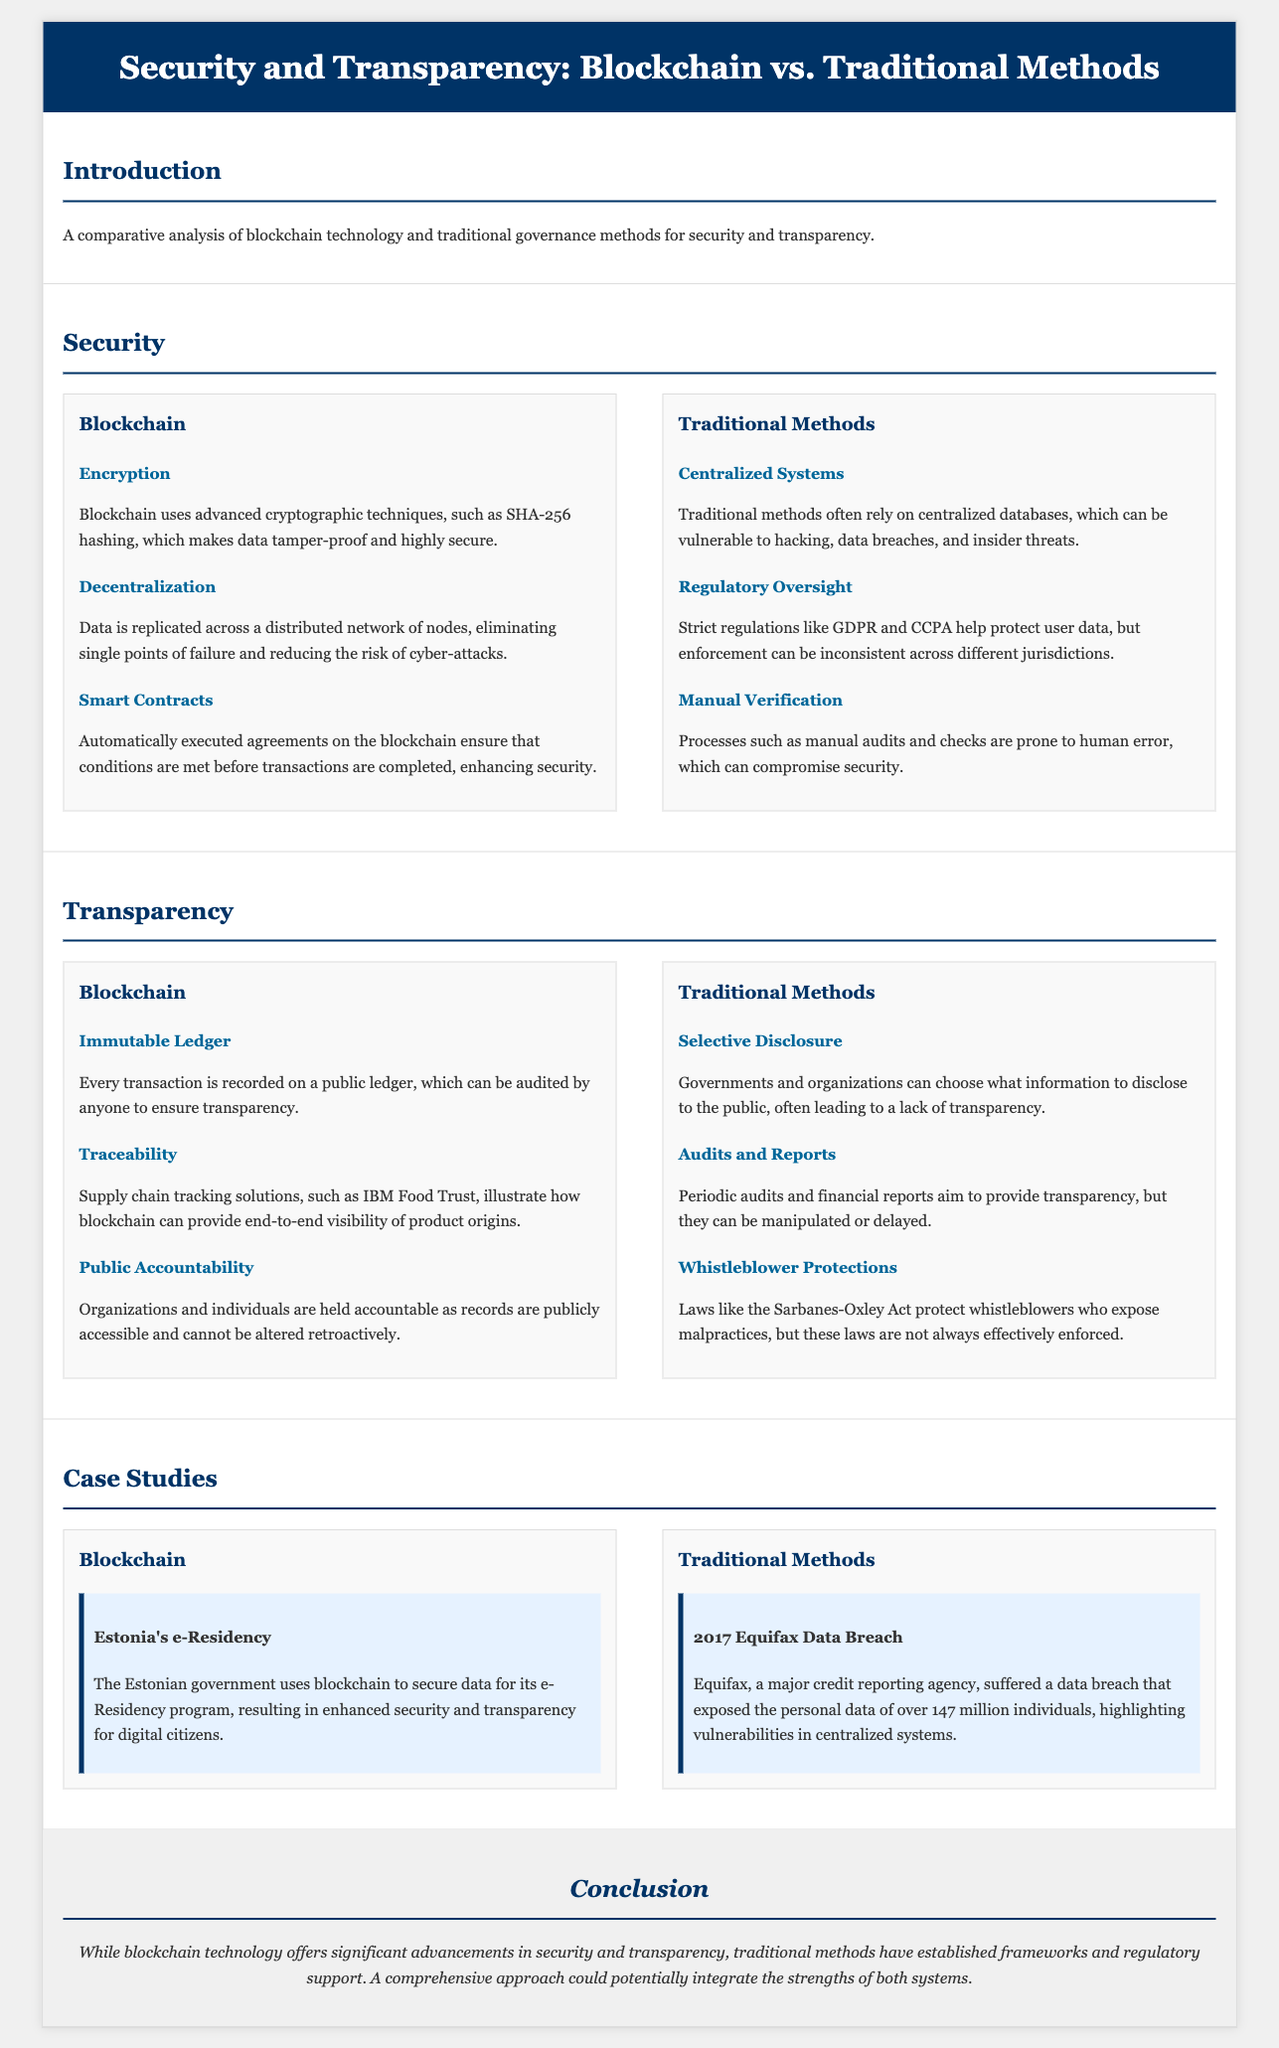What cryptographic technique does blockchain use? The document states that blockchain uses advanced cryptographic techniques, such as SHA-256 hashing.
Answer: SHA-256 hashing What is a consequence of decentralized data in blockchain? Decentralization eliminates single points of failure and reduces the risk of cyber-attacks.
Answer: Reduces cyber-attack risk What is one benefit of smart contracts in blockchain? Smart contracts ensure that conditions are met before transactions are completed, enhancing security.
Answer: Enhances security Which act protects whistleblowers in traditional methods? The document mentions the Sarbanes-Oxley Act as a law that protects whistleblowers who expose malpractices.
Answer: Sarbanes-Oxley Act What data breach example highlights vulnerabilities in centralized systems? The document cites the Equifax data breach that exposed the personal data of over 147 million individuals.
Answer: Equifax data breach What tracking solution demonstrates blockchain's traceability? The document references IBM Food Trust as a supply chain tracking solution showcasing blockchain's capabilities.
Answer: IBM Food Trust What type of ledger does blockchain provide? The document indicates that blockchain has an immutable ledger for recording every transaction.
Answer: Immutable ledger What is a limitation of traditional methods regarding information disclosure? Traditional methods allow governments and organizations to choose what information to disclose, leading to potential lack of transparency.
Answer: Selective disclosure What does Estonia use blockchain for in their e-Residency program? The document states that Estonia uses blockchain to secure data for its e-Residency program.
Answer: Secure data for e-Residency 